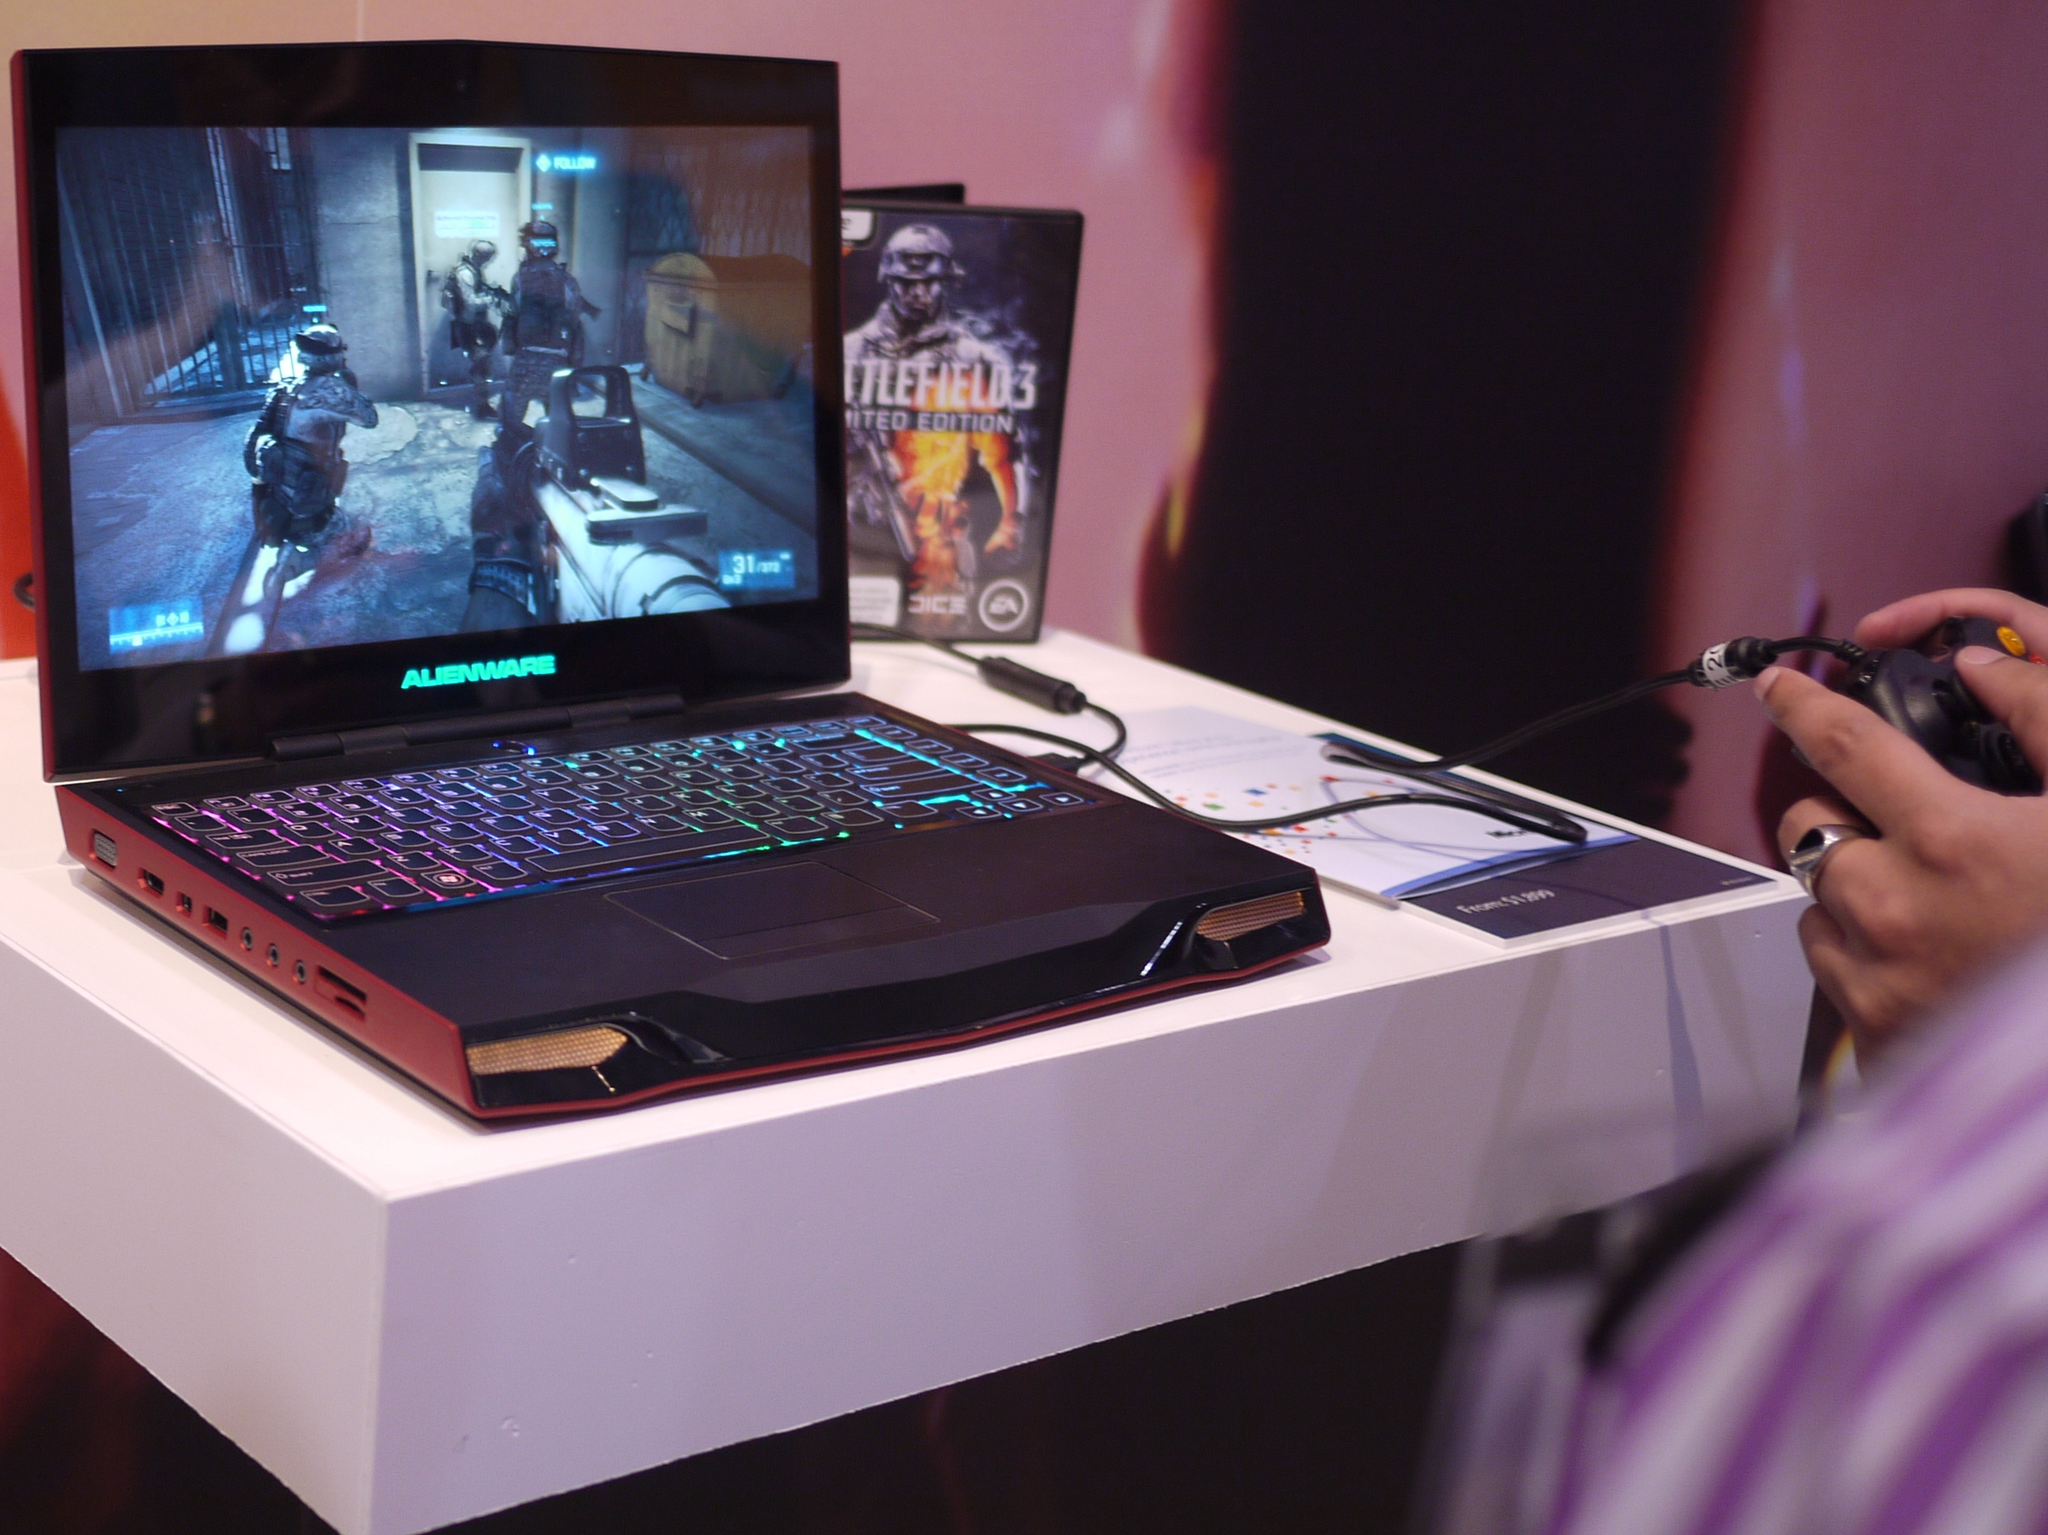<image>
Offer a succinct explanation of the picture presented. A game box titled Battlefield 3 sits behind a laptop with a game playing. 